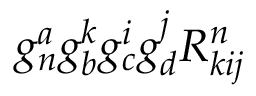<formula> <loc_0><loc_0><loc_500><loc_500>g _ { n } ^ { a } g _ { b } ^ { k } g _ { c } ^ { i } g _ { d } ^ { j } R _ { k i j } ^ { n }</formula> 